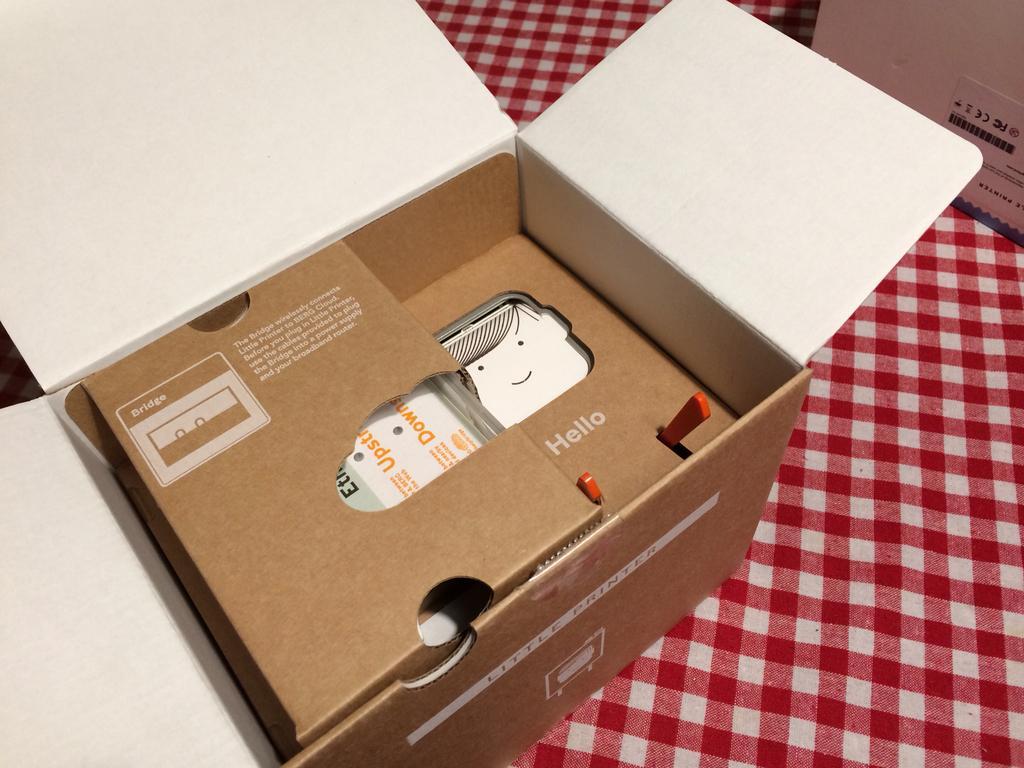How would you summarize this image in a sentence or two? In this image we can see two boxes on the cloth and there are few objects in a box. 